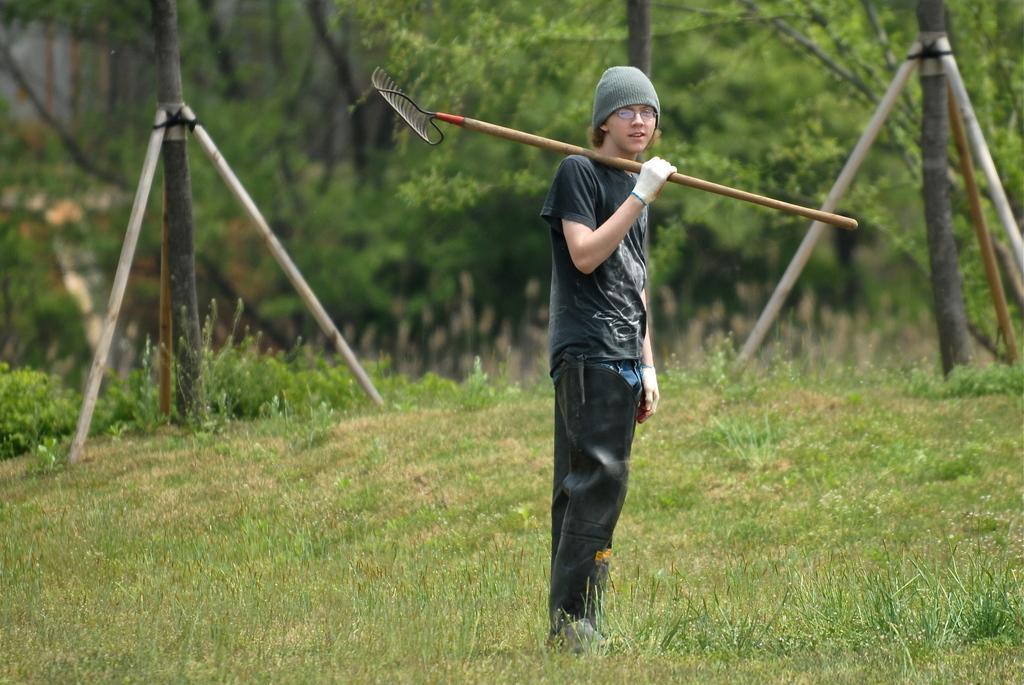Could you give a brief overview of what you see in this image? In this image, we can see a person holding an object. We can see the ground covered with grass, plants. We can also see some poles and trees. We can also see the blurred background. 